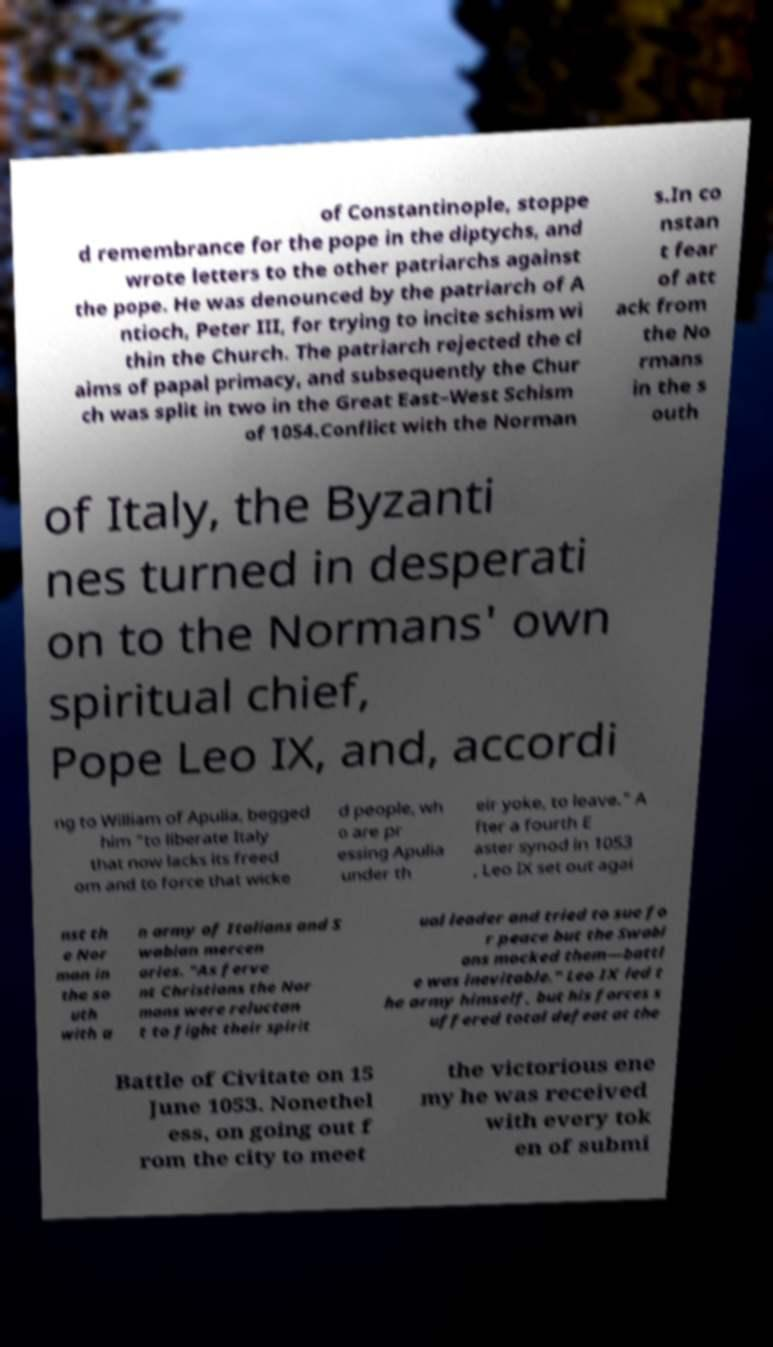What messages or text are displayed in this image? I need them in a readable, typed format. of Constantinople, stoppe d remembrance for the pope in the diptychs, and wrote letters to the other patriarchs against the pope. He was denounced by the patriarch of A ntioch, Peter III, for trying to incite schism wi thin the Church. The patriarch rejected the cl aims of papal primacy, and subsequently the Chur ch was split in two in the Great East–West Schism of 1054.Conflict with the Norman s.In co nstan t fear of att ack from the No rmans in the s outh of Italy, the Byzanti nes turned in desperati on to the Normans' own spiritual chief, Pope Leo IX, and, accordi ng to William of Apulia, begged him "to liberate Italy that now lacks its freed om and to force that wicke d people, wh o are pr essing Apulia under th eir yoke, to leave." A fter a fourth E aster synod in 1053 , Leo IX set out agai nst th e Nor man in the so uth with a n army of Italians and S wabian mercen aries. "As ferve nt Christians the Nor mans were reluctan t to fight their spirit ual leader and tried to sue fo r peace but the Swabi ans mocked them—battl e was inevitable." Leo IX led t he army himself, but his forces s uffered total defeat at the Battle of Civitate on 15 June 1053. Nonethel ess, on going out f rom the city to meet the victorious ene my he was received with every tok en of submi 